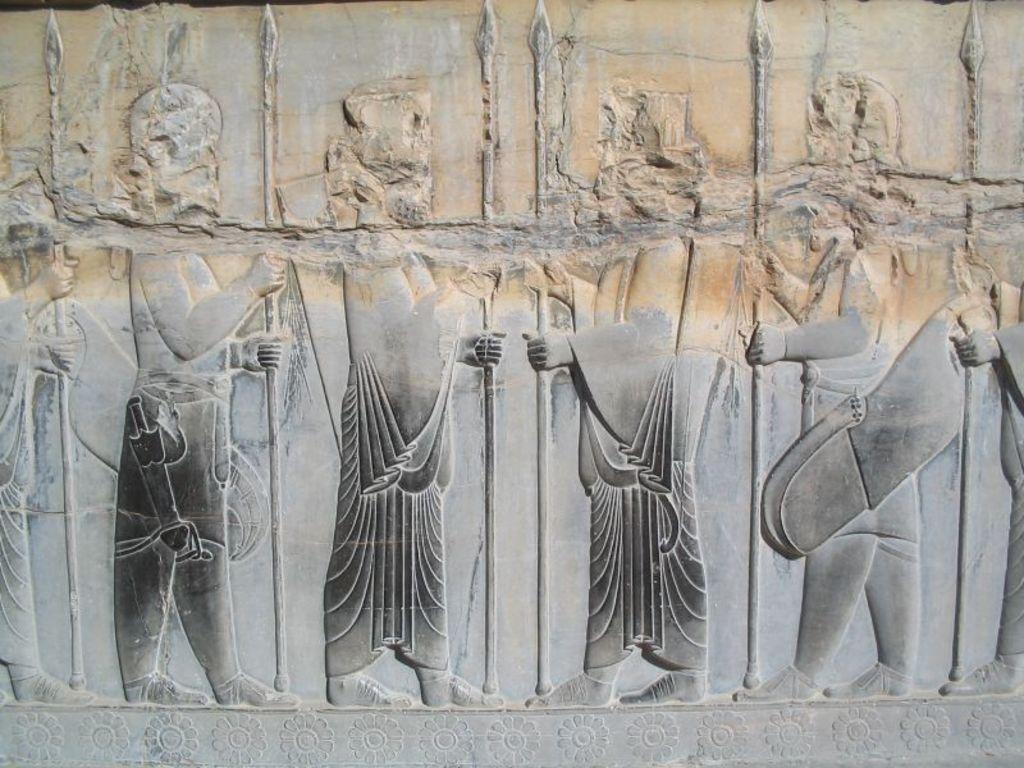Could you give a brief overview of what you see in this image? In the image on the stone there are few sculptures of people with holding the rods in their hands. At the bottom of the image on the stone there are flower sculptures. 